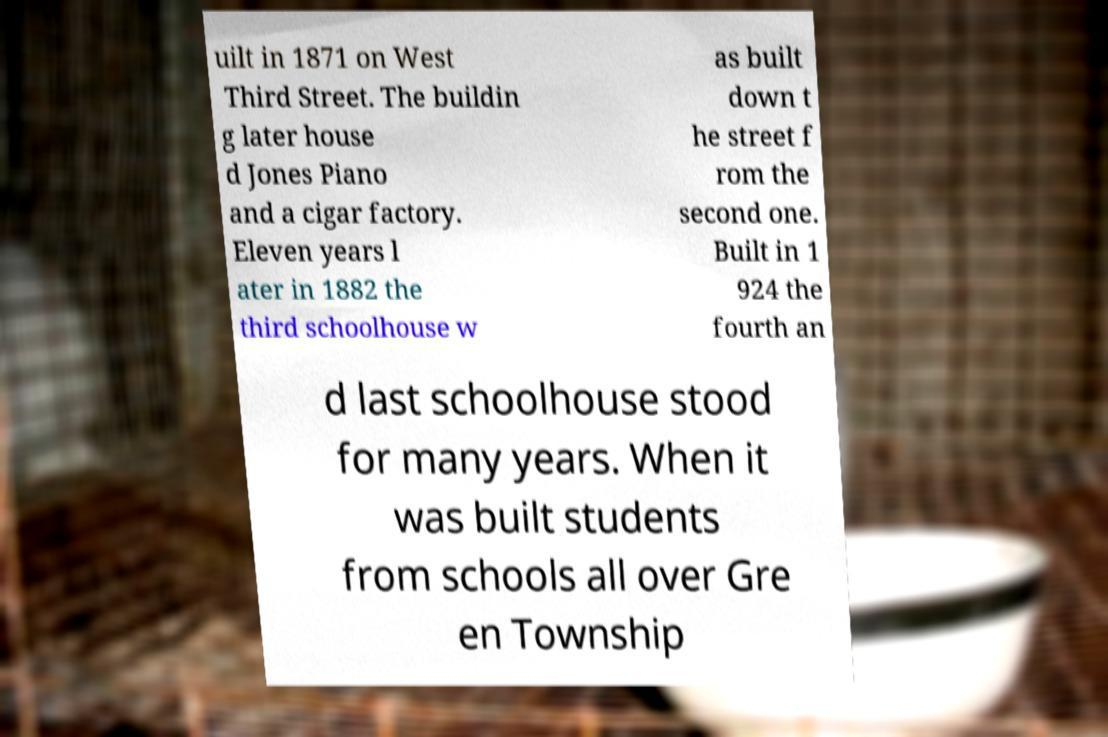Can you accurately transcribe the text from the provided image for me? uilt in 1871 on West Third Street. The buildin g later house d Jones Piano and a cigar factory. Eleven years l ater in 1882 the third schoolhouse w as built down t he street f rom the second one. Built in 1 924 the fourth an d last schoolhouse stood for many years. When it was built students from schools all over Gre en Township 